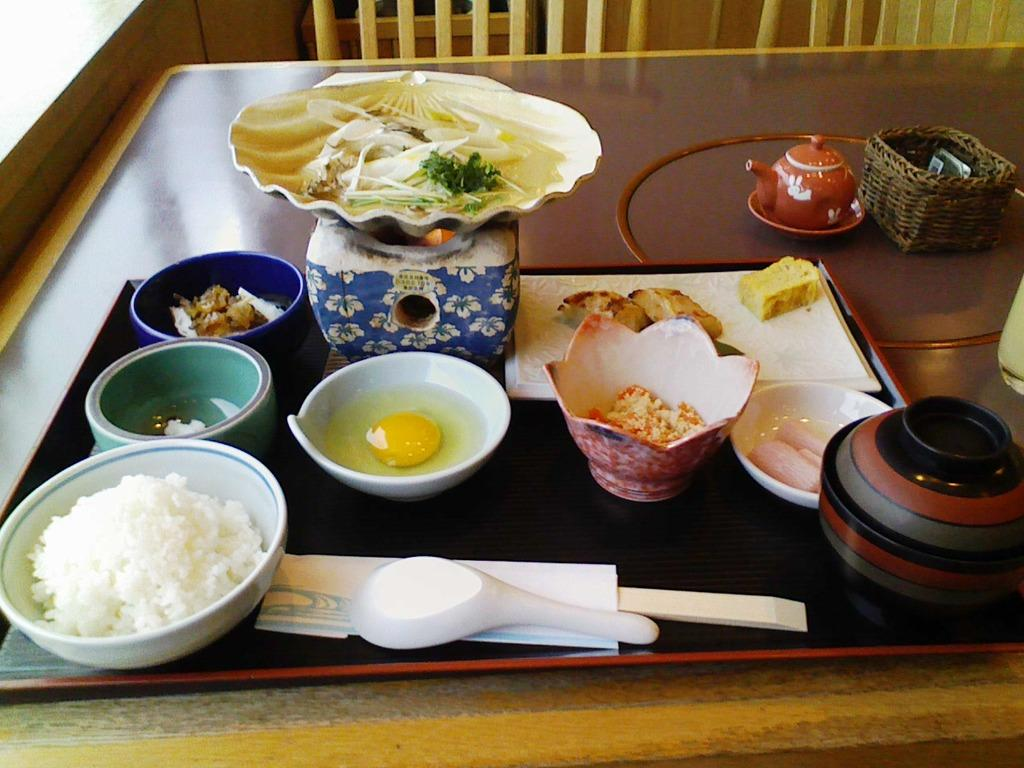What is the main piece of furniture in the image? There is a table in the image. What is placed on the table? There are food items served in bowls on the table. Are there any other objects visible in the image? Yes, there are other objects beside the table. What type of tail can be seen on the food items in the image? There are no tails present on the food items in the image. What kind of soap is used to clean the table in the image? There is no soap or cleaning activity depicted in the image. 